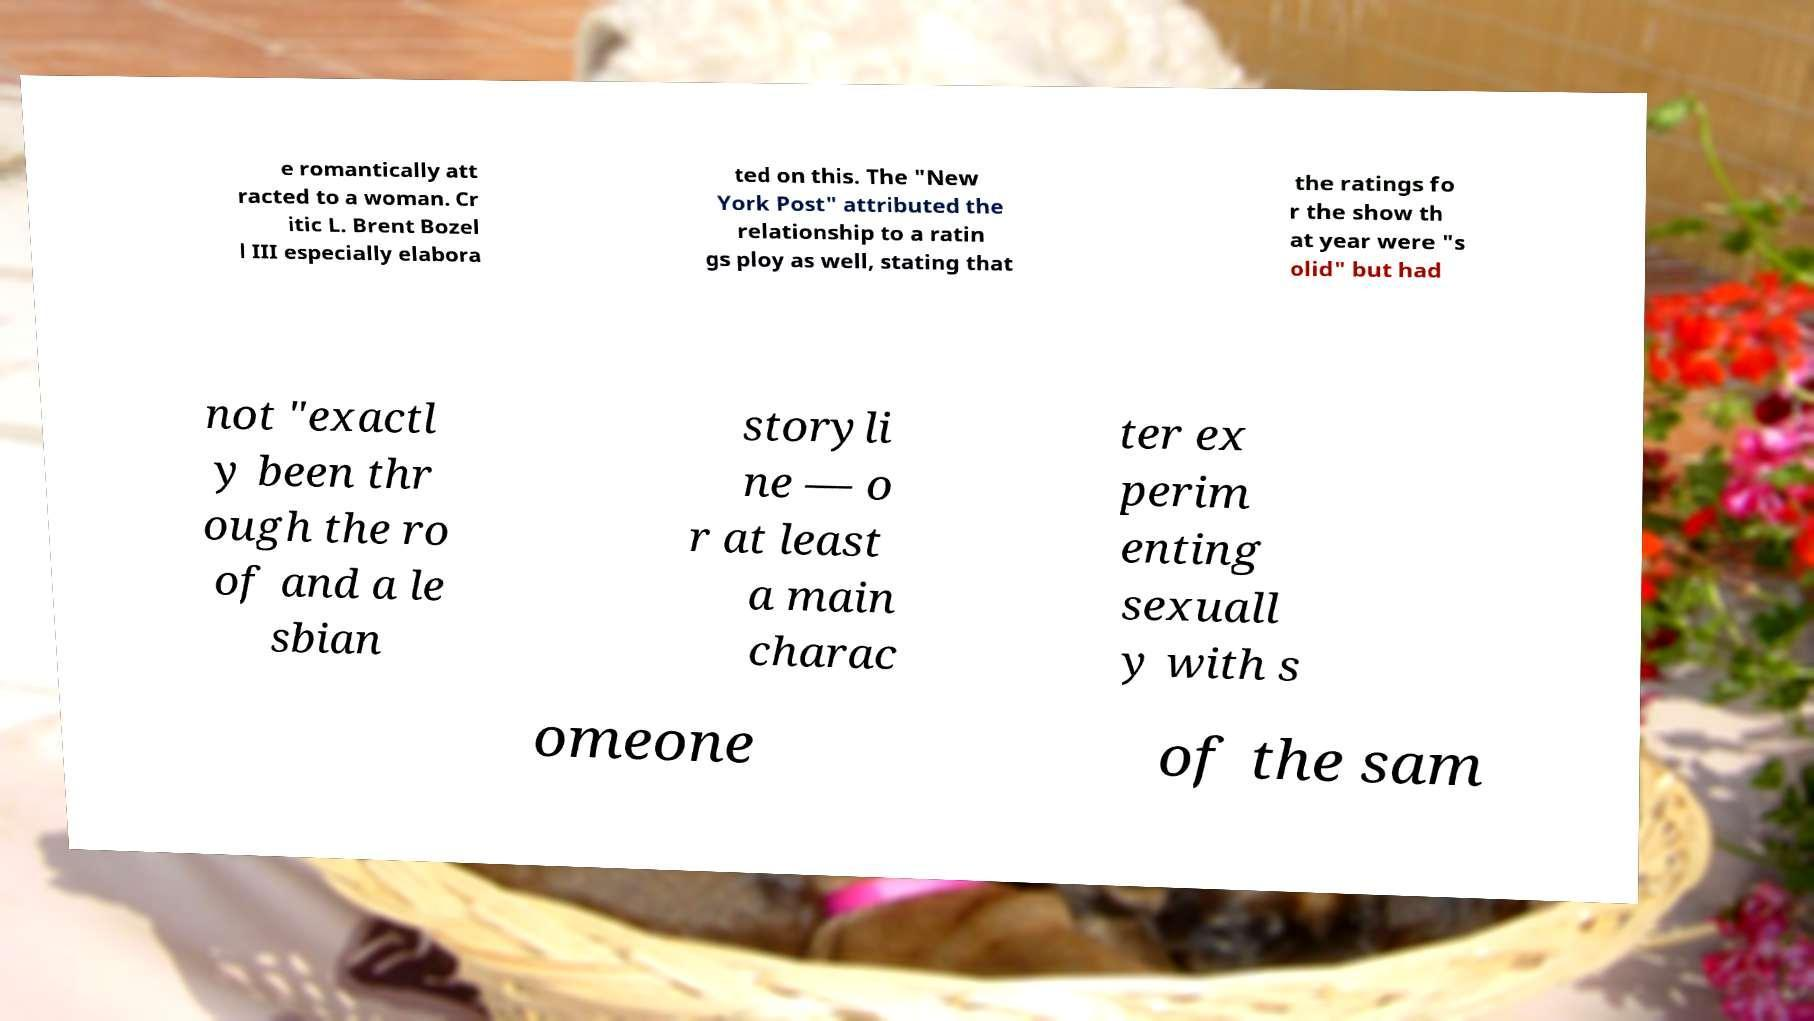Can you read and provide the text displayed in the image?This photo seems to have some interesting text. Can you extract and type it out for me? e romantically att racted to a woman. Cr itic L. Brent Bozel l III especially elabora ted on this. The "New York Post" attributed the relationship to a ratin gs ploy as well, stating that the ratings fo r the show th at year were "s olid" but had not "exactl y been thr ough the ro of and a le sbian storyli ne — o r at least a main charac ter ex perim enting sexuall y with s omeone of the sam 